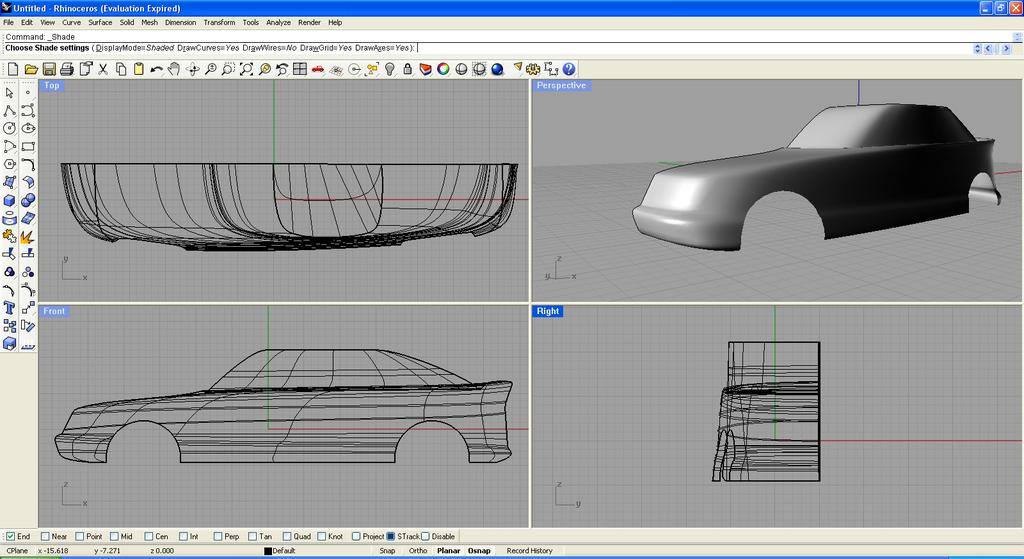What type of image is being described? The image is graphical in nature. Can you provide any additional information about the image? The image appears to be a screenshot. What type of magic is being performed in the image? There is no magic or any indication of magic in the image. Can you tell me what type of turkey is featured in the image? There is no turkey present in the image. 